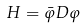Convert formula to latex. <formula><loc_0><loc_0><loc_500><loc_500>H = \bar { \varphi } D \varphi</formula> 